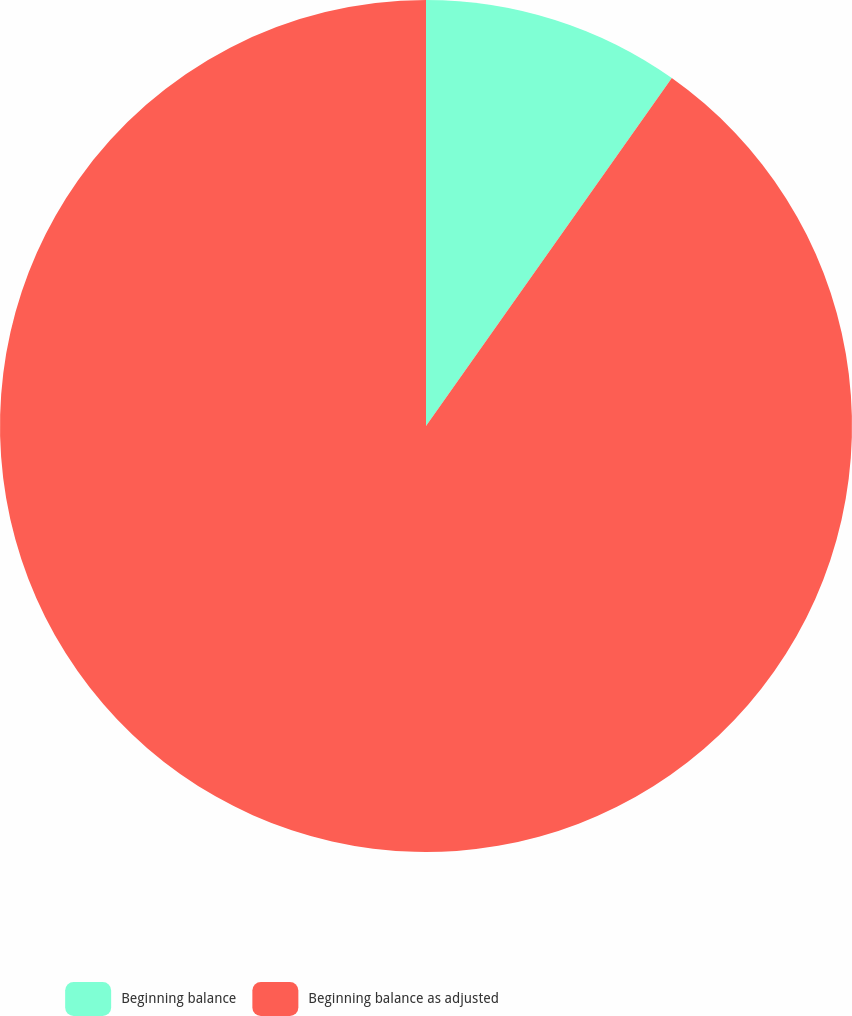Convert chart to OTSL. <chart><loc_0><loc_0><loc_500><loc_500><pie_chart><fcel>Beginning balance<fcel>Beginning balance as adjusted<nl><fcel>9.79%<fcel>90.21%<nl></chart> 